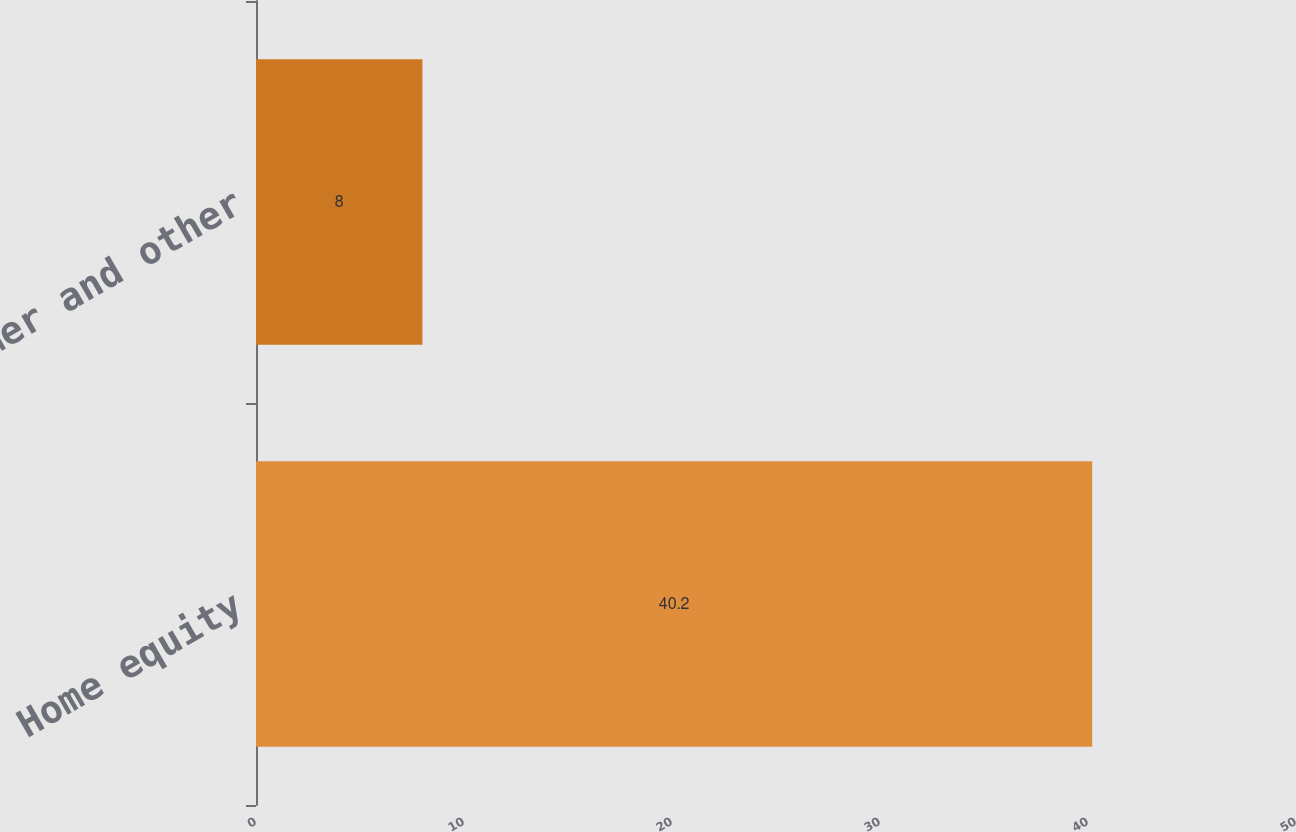Convert chart. <chart><loc_0><loc_0><loc_500><loc_500><bar_chart><fcel>Home equity<fcel>Consumer and other<nl><fcel>40.2<fcel>8<nl></chart> 